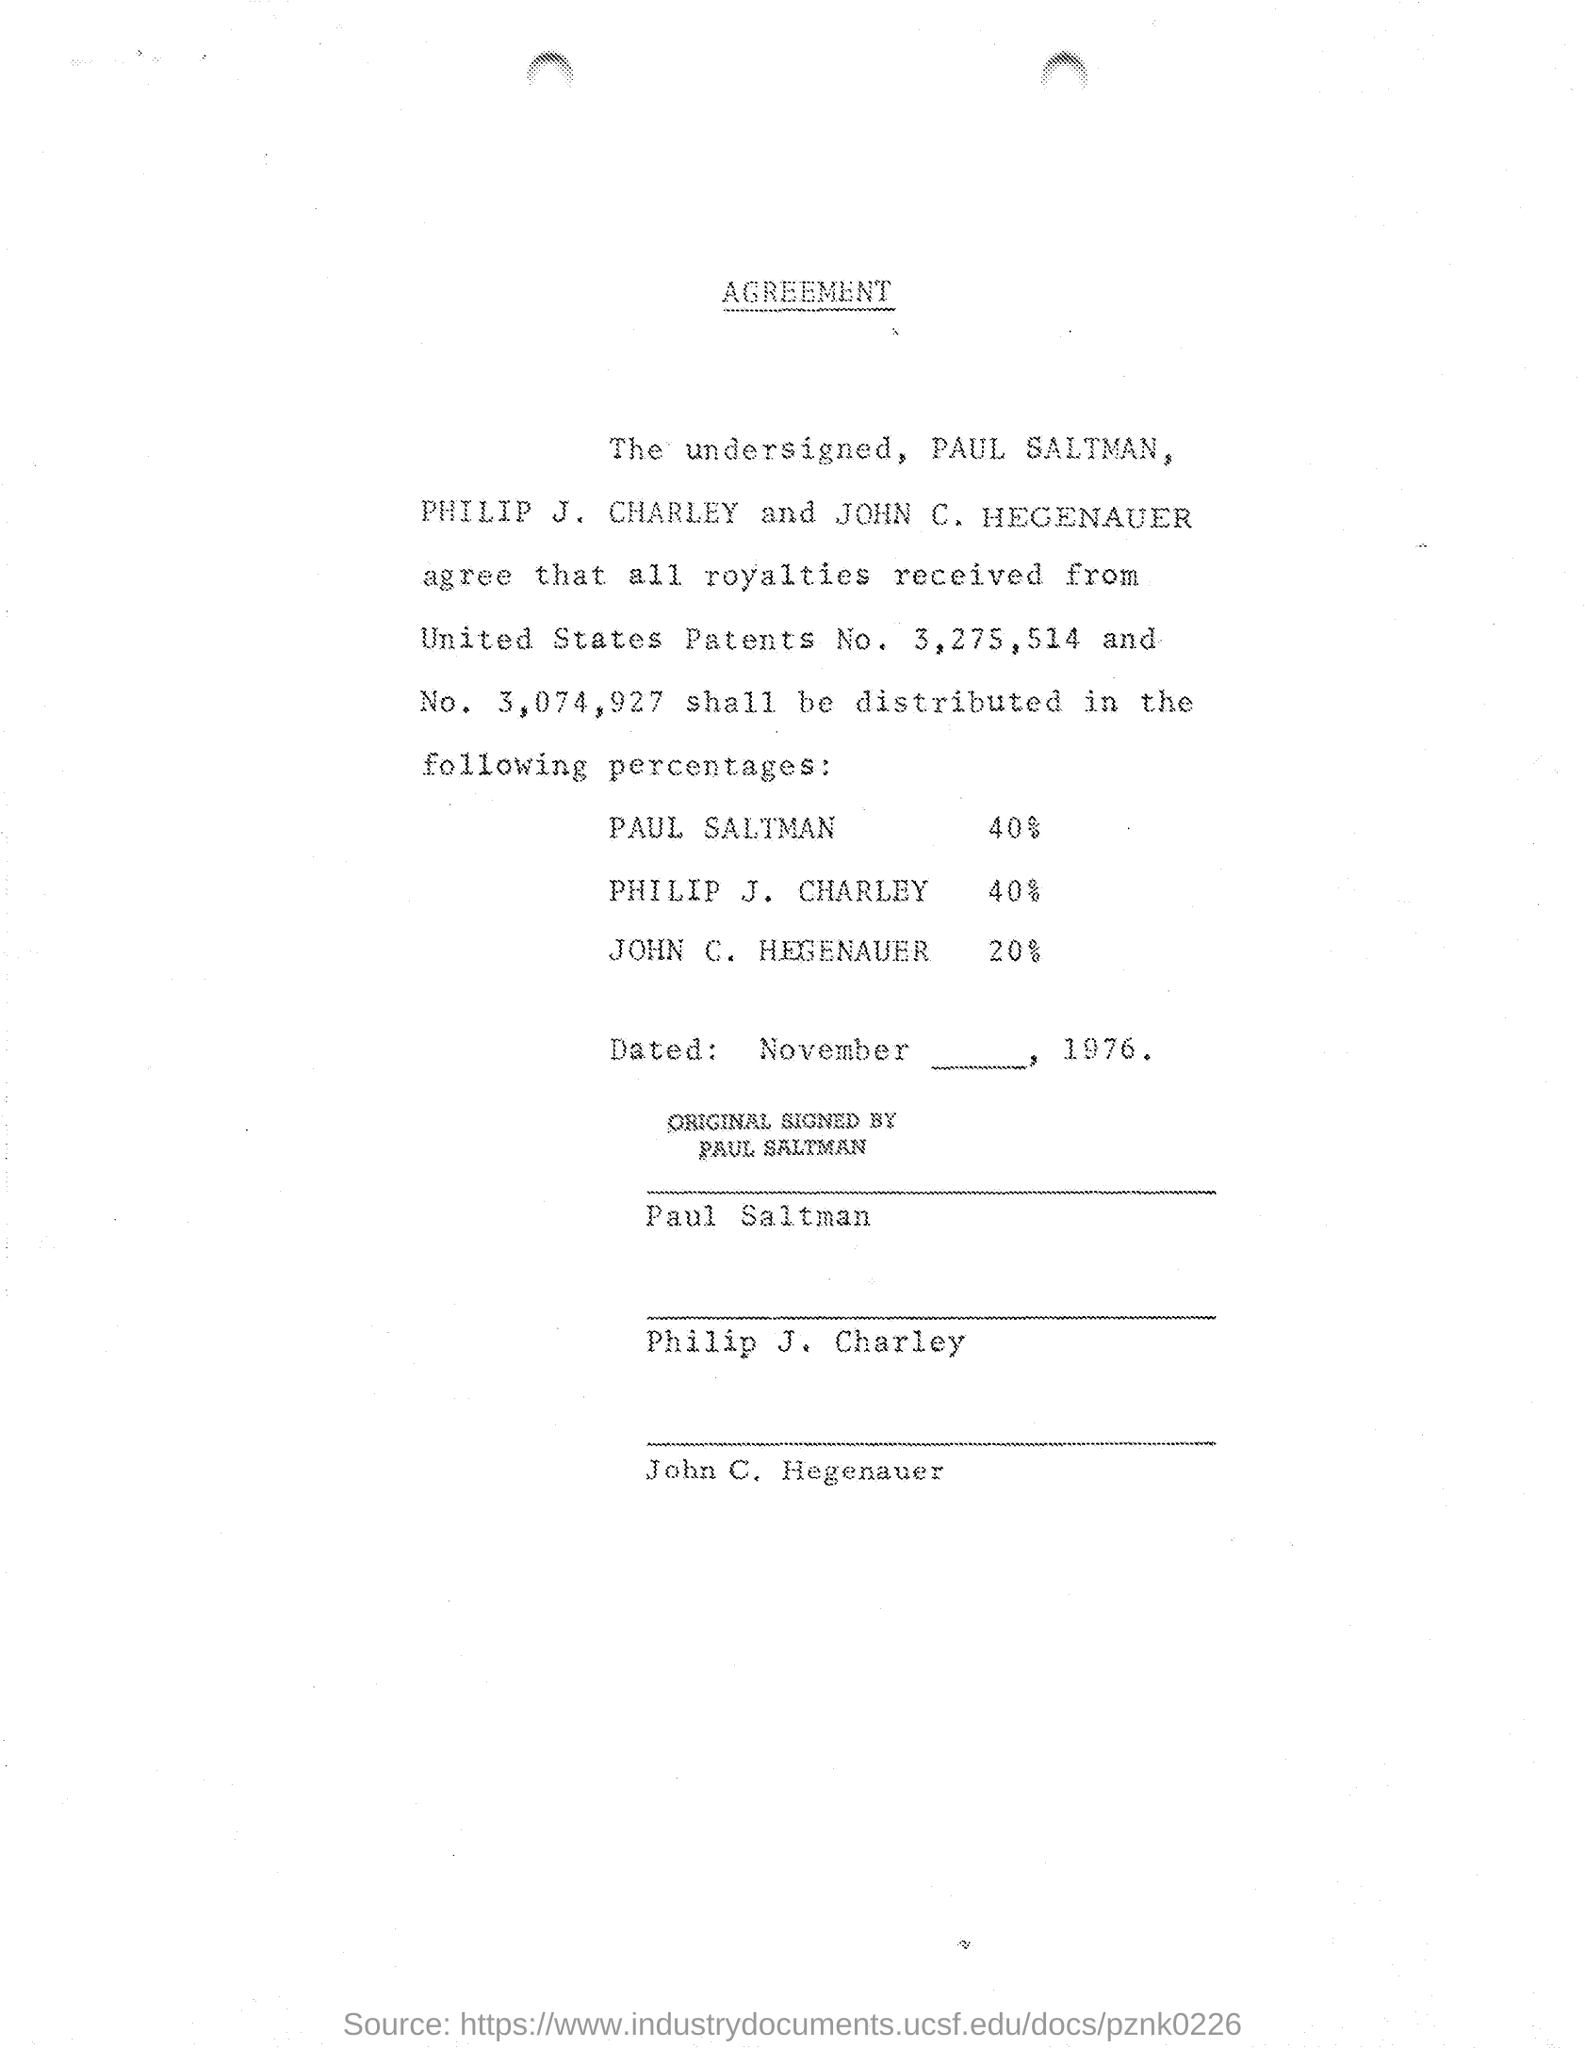What percentage of royalty is given to PAUL SALTMAN as per the document?
Offer a very short reply. 40%. What percentage of royalty is given to PHILIP J. CHARLEY as per the document?
Ensure brevity in your answer.  40%. What percentage of royalty is given to JOHN C. HEGENAUER as per the document?
Provide a short and direct response. 20%. 